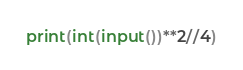<code> <loc_0><loc_0><loc_500><loc_500><_Python_>print(int(input())**2//4)</code> 